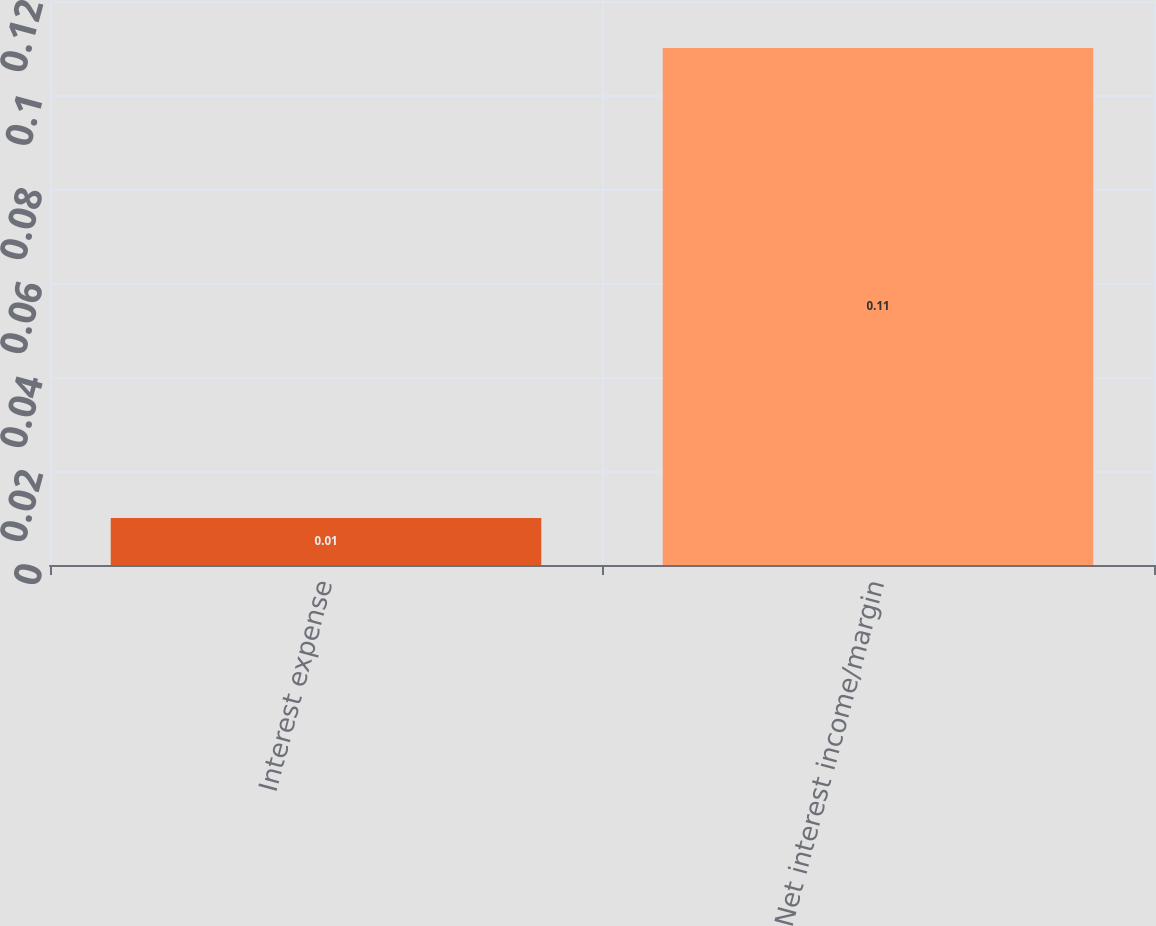<chart> <loc_0><loc_0><loc_500><loc_500><bar_chart><fcel>Interest expense<fcel>Net interest income/margin<nl><fcel>0.01<fcel>0.11<nl></chart> 